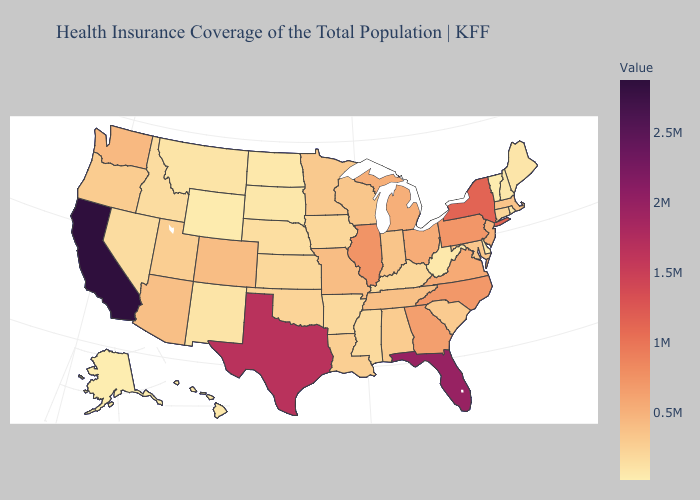Among the states that border South Carolina , does Georgia have the lowest value?
Write a very short answer. Yes. Does Utah have the highest value in the West?
Be succinct. No. Is the legend a continuous bar?
Answer briefly. Yes. Which states have the lowest value in the MidWest?
Concise answer only. North Dakota. Does Kentucky have the lowest value in the South?
Write a very short answer. No. 